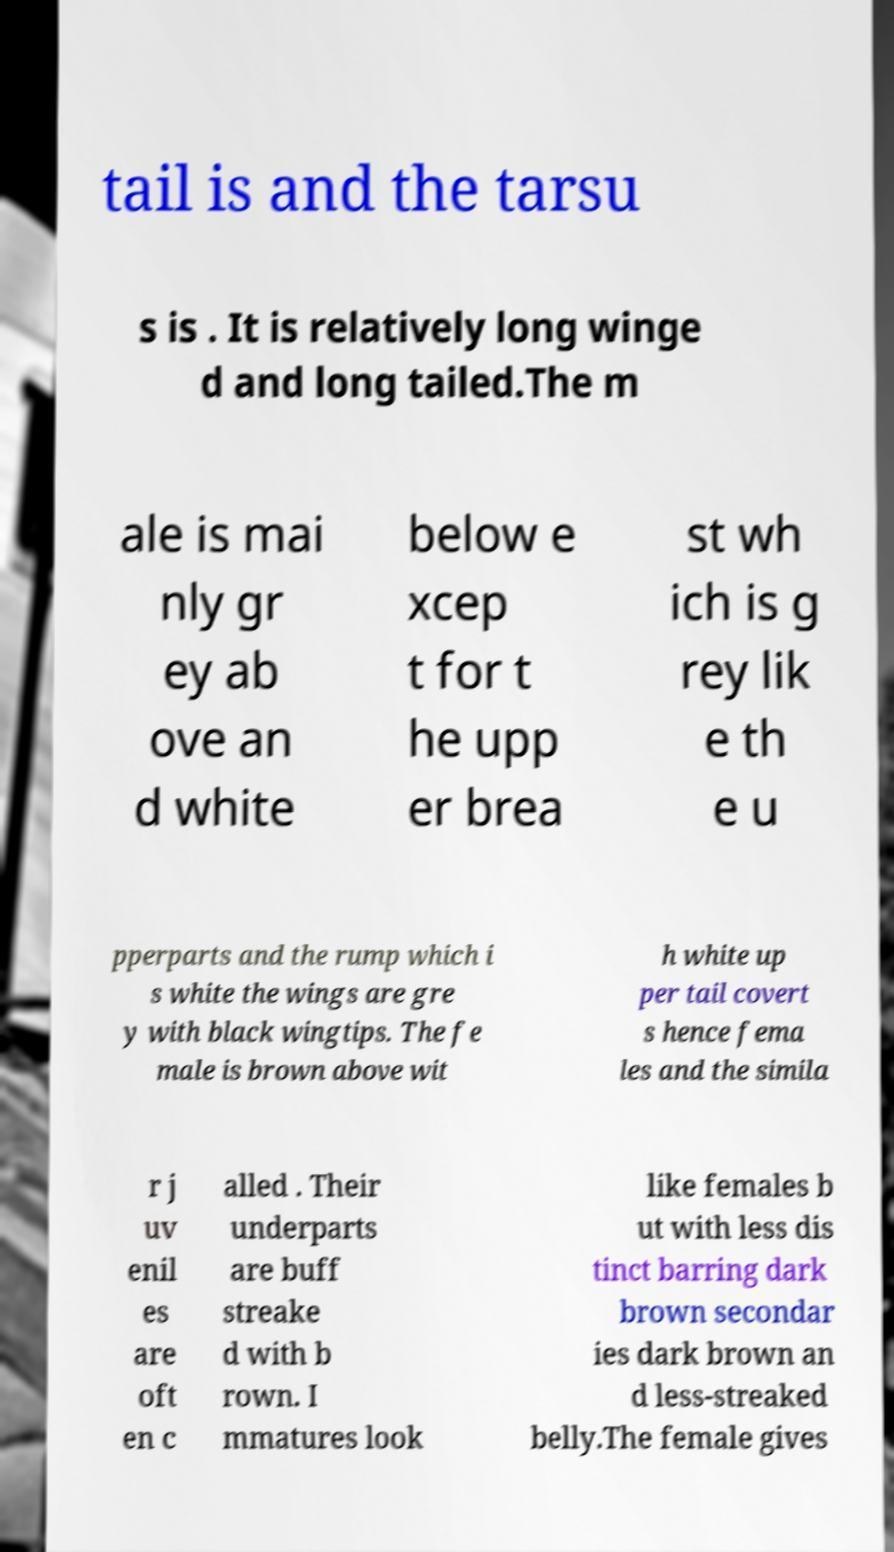Can you read and provide the text displayed in the image?This photo seems to have some interesting text. Can you extract and type it out for me? tail is and the tarsu s is . It is relatively long winge d and long tailed.The m ale is mai nly gr ey ab ove an d white below e xcep t for t he upp er brea st wh ich is g rey lik e th e u pperparts and the rump which i s white the wings are gre y with black wingtips. The fe male is brown above wit h white up per tail covert s hence fema les and the simila r j uv enil es are oft en c alled . Their underparts are buff streake d with b rown. I mmatures look like females b ut with less dis tinct barring dark brown secondar ies dark brown an d less-streaked belly.The female gives 